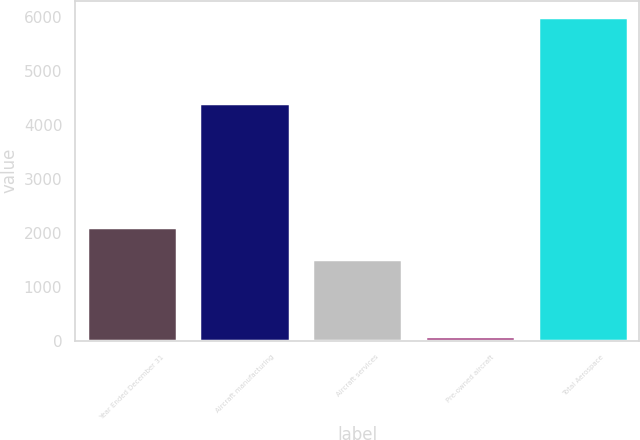Convert chart. <chart><loc_0><loc_0><loc_500><loc_500><bar_chart><fcel>Year Ended December 31<fcel>Aircraft manufacturing<fcel>Aircraft services<fcel>Pre-owned aircraft<fcel>Total Aerospace<nl><fcel>2113.1<fcel>4400<fcel>1521<fcel>77<fcel>5998<nl></chart> 